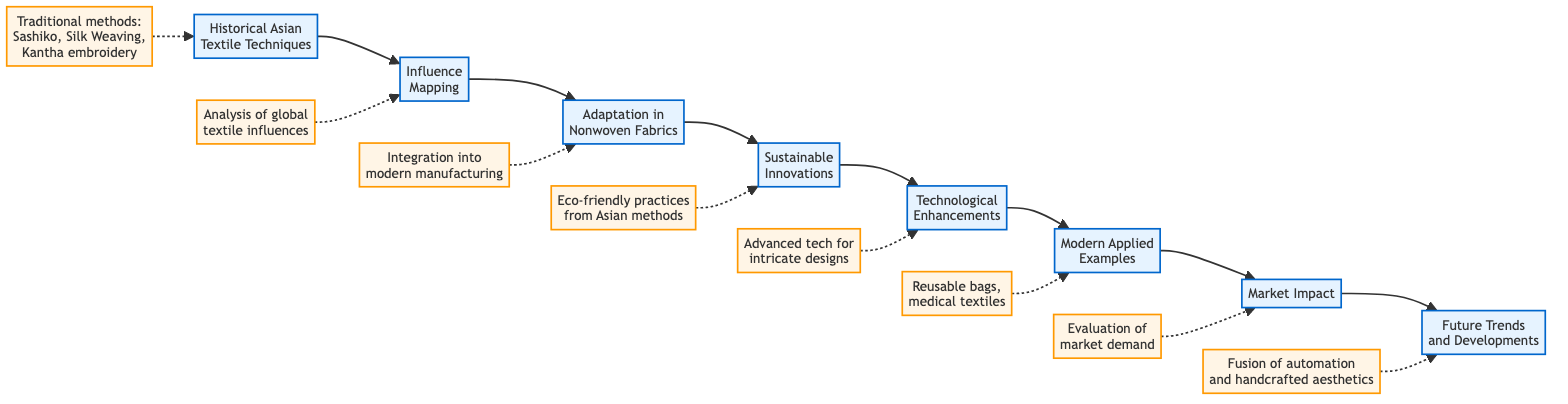What is the first step in the flowchart? The first step in the flowchart is “Historical Asian Textile Techniques.” It is the initial node that serves as the starting point of the process.
Answer: Historical Asian Textile Techniques How many steps are there in the flowchart? By counting the nodes from the first step to the last, there are a total of eight steps in the flowchart. Each node represents a specific stage in the process.
Answer: Eight What technique is integrated into modern manufacturing? The integration mentioned in the flowchart is related to “historical techniques into modern manufacturing processes.” This refers specifically to digitally printing traditional patterns onto nonwoven polypropylene fabrics.
Answer: Historical techniques Which step discusses eco-friendly practices? The fourth step, titled “Sustainable Innovations,” specifically discusses the incorporation of eco-friendly practices inspired by traditional Asian methods, such as natural dyeing techniques.
Answer: Sustainable Innovations How does “Modern Applied Examples” relate to earlier steps? “Modern Applied Examples,” the sixth step, relates directly to earlier steps by showcasing products that combine traditional aesthetics and modern nonwoven materials, thus bridging historical techniques and contemporary applications.
Answer: Products combination What is the focus of the seventh step in the flowchart? The focus of the seventh step, “Market Impact,” is on evaluating market demand and consumer preferences for products that integrate cross-cultural influences, emphasizing sustainability and cultural heritage as key aspects.
Answer: Market demand and consumer preferences What traditional technique inspired laser-cutting technology? The traditional technique that inspired laser-cutting technology is related to “Japanese stencils,” specifically referred to as “Katagami” in the flowchart under the step discussing technological enhancements.
Answer: Katagami Which two concepts are connected in the last step? The last step, “Future Trends and Developments,” connects the concepts of “automated manufacturing” with “handcrafted aesthetics,” indicating a trend towards blending these two aspects in the future.
Answer: Automated manufacturing and handcrafted aesthetics 